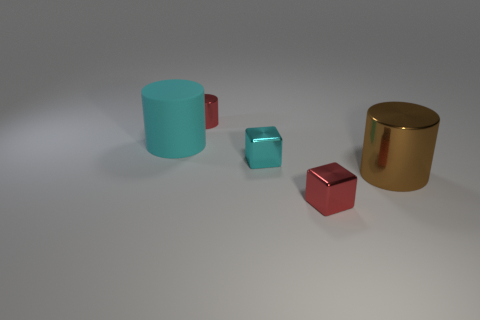There is a metal cylinder right of the cyan metal thing; what size is it?
Offer a terse response. Large. There is a cyan matte cylinder; does it have the same size as the metal cylinder in front of the red shiny cylinder?
Offer a terse response. Yes. Is the number of shiny blocks that are left of the brown metallic object less than the number of tiny gray matte cylinders?
Ensure brevity in your answer.  No. There is another small thing that is the same shape as the cyan shiny object; what material is it?
Ensure brevity in your answer.  Metal. What is the shape of the object that is on the right side of the big matte cylinder and to the left of the cyan metal block?
Make the answer very short. Cylinder. There is a tiny cyan thing that is made of the same material as the tiny red cylinder; what shape is it?
Your answer should be very brief. Cube. What is the material of the small red object behind the brown cylinder?
Your answer should be very brief. Metal. There is a shiny thing that is behind the big cyan matte cylinder; is it the same size as the red metallic thing in front of the cyan metal cube?
Provide a short and direct response. Yes. The large metal object is what color?
Your answer should be very brief. Brown. There is a red object in front of the tiny red cylinder; is it the same shape as the big cyan object?
Ensure brevity in your answer.  No. 